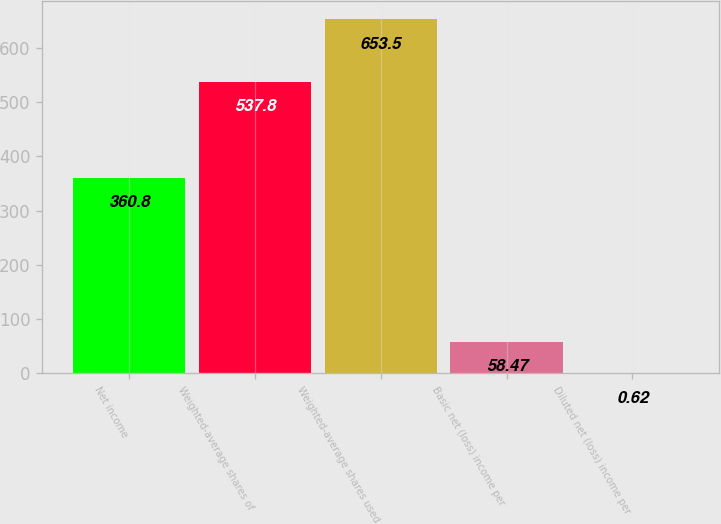Convert chart to OTSL. <chart><loc_0><loc_0><loc_500><loc_500><bar_chart><fcel>Net income<fcel>Weighted-average shares of<fcel>Weighted-average shares used<fcel>Basic net (loss) income per<fcel>Diluted net (loss) income per<nl><fcel>360.8<fcel>537.8<fcel>653.5<fcel>58.47<fcel>0.62<nl></chart> 